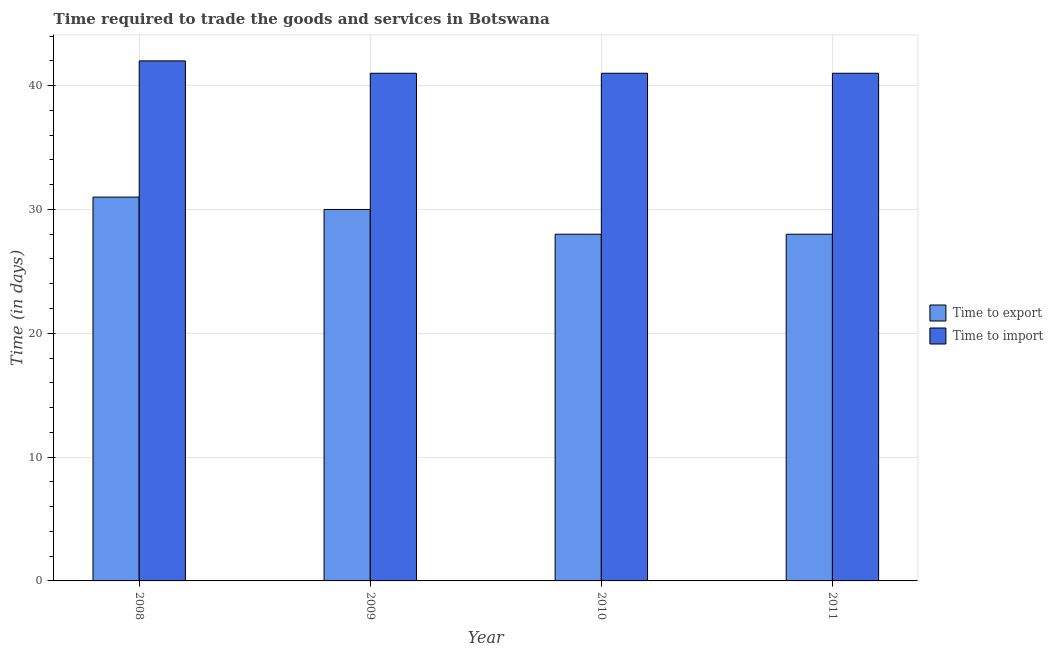How many different coloured bars are there?
Your answer should be compact. 2. Are the number of bars per tick equal to the number of legend labels?
Ensure brevity in your answer.  Yes. Are the number of bars on each tick of the X-axis equal?
Your answer should be compact. Yes. What is the label of the 2nd group of bars from the left?
Ensure brevity in your answer.  2009. In how many cases, is the number of bars for a given year not equal to the number of legend labels?
Keep it short and to the point. 0. What is the time to export in 2010?
Your answer should be very brief. 28. Across all years, what is the maximum time to export?
Your response must be concise. 31. Across all years, what is the minimum time to import?
Provide a succinct answer. 41. What is the total time to import in the graph?
Keep it short and to the point. 165. What is the difference between the time to export in 2009 and that in 2011?
Provide a succinct answer. 2. What is the difference between the time to export in 2011 and the time to import in 2008?
Offer a terse response. -3. What is the average time to export per year?
Give a very brief answer. 29.25. In the year 2011, what is the difference between the time to import and time to export?
Your answer should be very brief. 0. What is the ratio of the time to export in 2008 to that in 2011?
Offer a very short reply. 1.11. What is the difference between the highest and the lowest time to export?
Your response must be concise. 3. Is the sum of the time to import in 2008 and 2009 greater than the maximum time to export across all years?
Offer a terse response. Yes. What does the 1st bar from the left in 2010 represents?
Provide a short and direct response. Time to export. What does the 2nd bar from the right in 2010 represents?
Your response must be concise. Time to export. How many bars are there?
Make the answer very short. 8. Are the values on the major ticks of Y-axis written in scientific E-notation?
Your answer should be compact. No. Does the graph contain any zero values?
Provide a short and direct response. No. Where does the legend appear in the graph?
Offer a very short reply. Center right. How many legend labels are there?
Give a very brief answer. 2. How are the legend labels stacked?
Your answer should be compact. Vertical. What is the title of the graph?
Provide a short and direct response. Time required to trade the goods and services in Botswana. What is the label or title of the Y-axis?
Offer a terse response. Time (in days). What is the Time (in days) of Time to export in 2008?
Ensure brevity in your answer.  31. What is the Time (in days) in Time to export in 2009?
Offer a terse response. 30. What is the Time (in days) in Time to import in 2009?
Your answer should be compact. 41. What is the Time (in days) in Time to export in 2010?
Ensure brevity in your answer.  28. What is the Time (in days) of Time to import in 2010?
Ensure brevity in your answer.  41. What is the Time (in days) of Time to import in 2011?
Provide a succinct answer. 41. Across all years, what is the maximum Time (in days) of Time to export?
Your response must be concise. 31. Across all years, what is the minimum Time (in days) in Time to export?
Provide a short and direct response. 28. What is the total Time (in days) in Time to export in the graph?
Keep it short and to the point. 117. What is the total Time (in days) in Time to import in the graph?
Give a very brief answer. 165. What is the difference between the Time (in days) of Time to import in 2008 and that in 2009?
Ensure brevity in your answer.  1. What is the difference between the Time (in days) in Time to export in 2008 and that in 2011?
Give a very brief answer. 3. What is the difference between the Time (in days) in Time to import in 2008 and that in 2011?
Ensure brevity in your answer.  1. What is the difference between the Time (in days) in Time to import in 2009 and that in 2010?
Provide a succinct answer. 0. What is the difference between the Time (in days) in Time to export in 2009 and that in 2011?
Your response must be concise. 2. What is the difference between the Time (in days) in Time to import in 2009 and that in 2011?
Provide a succinct answer. 0. What is the difference between the Time (in days) of Time to import in 2010 and that in 2011?
Provide a short and direct response. 0. What is the difference between the Time (in days) of Time to export in 2008 and the Time (in days) of Time to import in 2010?
Provide a succinct answer. -10. What is the difference between the Time (in days) of Time to export in 2008 and the Time (in days) of Time to import in 2011?
Your answer should be very brief. -10. What is the difference between the Time (in days) of Time to export in 2009 and the Time (in days) of Time to import in 2010?
Your response must be concise. -11. What is the difference between the Time (in days) of Time to export in 2009 and the Time (in days) of Time to import in 2011?
Make the answer very short. -11. What is the difference between the Time (in days) in Time to export in 2010 and the Time (in days) in Time to import in 2011?
Offer a terse response. -13. What is the average Time (in days) in Time to export per year?
Make the answer very short. 29.25. What is the average Time (in days) in Time to import per year?
Give a very brief answer. 41.25. In the year 2008, what is the difference between the Time (in days) of Time to export and Time (in days) of Time to import?
Provide a short and direct response. -11. In the year 2009, what is the difference between the Time (in days) in Time to export and Time (in days) in Time to import?
Ensure brevity in your answer.  -11. In the year 2010, what is the difference between the Time (in days) in Time to export and Time (in days) in Time to import?
Provide a short and direct response. -13. In the year 2011, what is the difference between the Time (in days) in Time to export and Time (in days) in Time to import?
Offer a very short reply. -13. What is the ratio of the Time (in days) in Time to import in 2008 to that in 2009?
Your answer should be compact. 1.02. What is the ratio of the Time (in days) of Time to export in 2008 to that in 2010?
Offer a terse response. 1.11. What is the ratio of the Time (in days) in Time to import in 2008 to that in 2010?
Offer a very short reply. 1.02. What is the ratio of the Time (in days) of Time to export in 2008 to that in 2011?
Keep it short and to the point. 1.11. What is the ratio of the Time (in days) in Time to import in 2008 to that in 2011?
Offer a very short reply. 1.02. What is the ratio of the Time (in days) of Time to export in 2009 to that in 2010?
Provide a succinct answer. 1.07. What is the ratio of the Time (in days) of Time to export in 2009 to that in 2011?
Provide a short and direct response. 1.07. What is the ratio of the Time (in days) in Time to export in 2010 to that in 2011?
Give a very brief answer. 1. What is the difference between the highest and the second highest Time (in days) in Time to export?
Provide a succinct answer. 1. What is the difference between the highest and the second highest Time (in days) in Time to import?
Ensure brevity in your answer.  1. 